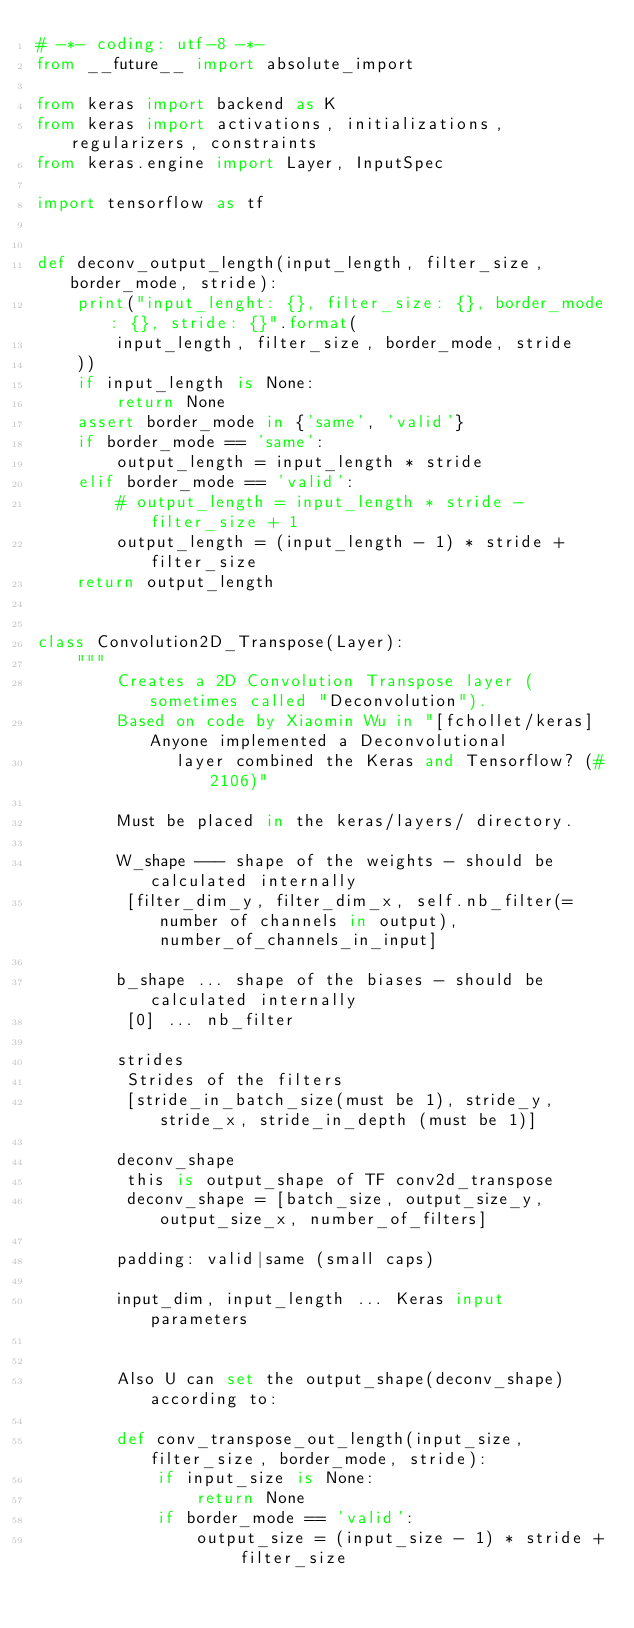Convert code to text. <code><loc_0><loc_0><loc_500><loc_500><_Python_># -*- coding: utf-8 -*-
from __future__ import absolute_import

from keras import backend as K
from keras import activations, initializations, regularizers, constraints
from keras.engine import Layer, InputSpec

import tensorflow as tf


def deconv_output_length(input_length, filter_size, border_mode, stride):
    print("input_lenght: {}, filter_size: {}, border_mode: {}, stride: {}".format(
        input_length, filter_size, border_mode, stride
    ))
    if input_length is None:
        return None
    assert border_mode in {'same', 'valid'}
    if border_mode == 'same':
        output_length = input_length * stride
    elif border_mode == 'valid':
        # output_length = input_length * stride - filter_size + 1
        output_length = (input_length - 1) * stride + filter_size
    return output_length


class Convolution2D_Transpose(Layer):
    """
        Creates a 2D Convolution Transpose layer (sometimes called "Deconvolution").
        Based on code by Xiaomin Wu in "[fchollet/keras] Anyone implemented a Deconvolutional                    
              layer combined the Keras and Tensorflow? (#2106)"

        Must be placed in the keras/layers/ directory.

        W_shape --- shape of the weights - should be calculated internally
         [filter_dim_y, filter_dim_x, self.nb_filter(=number of channels in output), number_of_channels_in_input]

        b_shape ... shape of the biases - should be calculated internally
         [0] ... nb_filter 

        strides 
         Strides of the filters
         [stride_in_batch_size(must be 1), stride_y, stride_x, stride_in_depth (must be 1)]

        deconv_shape
         this is output_shape of TF conv2d_transpose
         deconv_shape = [batch_size, output_size_y, output_size_x, number_of_filters]

        padding: valid|same (small caps)

        input_dim, input_length ... Keras input parameters


        Also U can set the output_shape(deconv_shape) according to:

        def conv_transpose_out_length(input_size, filter_size, border_mode, stride):
            if input_size is None:
                return None
            if border_mode == 'valid':
                output_size = (input_size - 1) * stride + filter_size</code> 